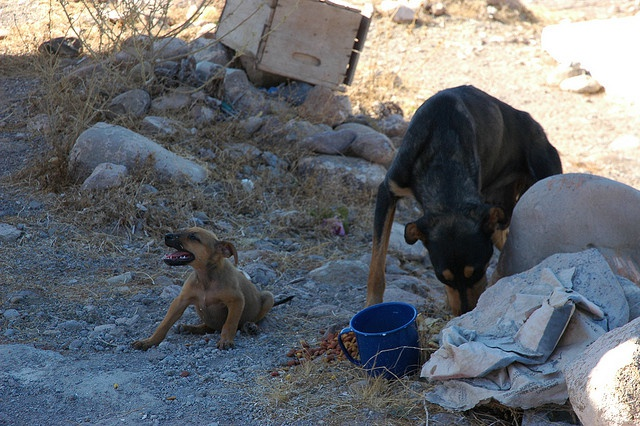Describe the objects in this image and their specific colors. I can see dog in beige, black, and gray tones, dog in beige, black, and gray tones, and cup in beige, black, navy, gray, and blue tones in this image. 